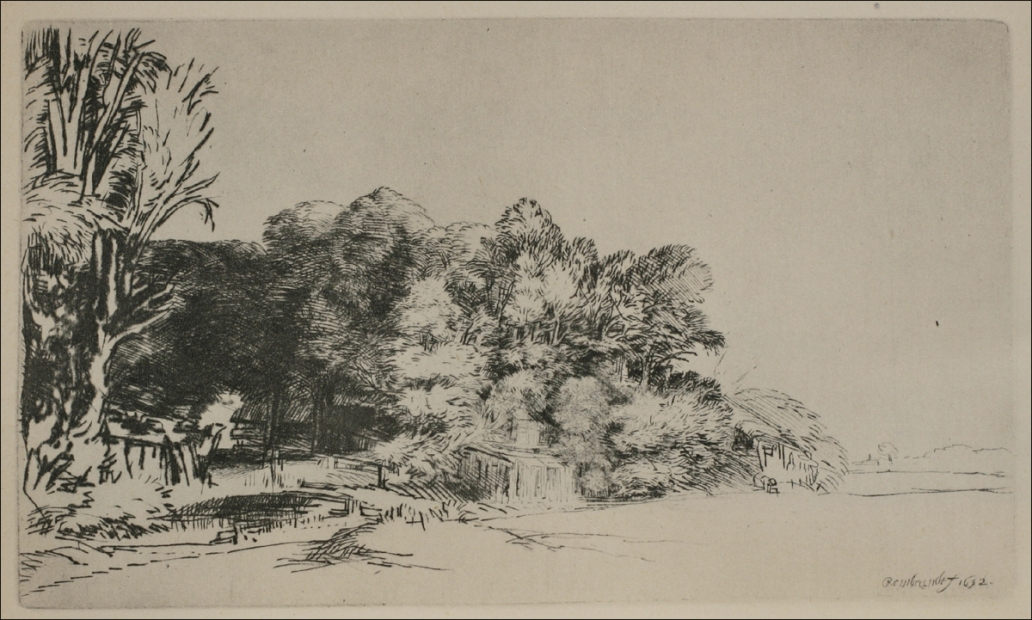What do you see happening in this image?
 The image is a black and white etching that beautifully captures a serene landscape scene. The scene is dominated by tall, leafy trees of various shapes and sizes, their detailed line work and shading adding a sense of depth and realism to the image. A path winds its way through the center of the image, inviting the viewer's eye to follow it deeper into the scene. A low fence lines this path, further enhancing the perspective. In the background, small buildings can be seen, adding an element of human presence to the otherwise natural landscape. The art style is realistic, with a keen attention to detail evident in the intricate line work and shading. The genre of the art is landscape, a timeless style that focuses on the natural world and our place within it. 